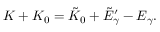Convert formula to latex. <formula><loc_0><loc_0><loc_500><loc_500>K + K _ { 0 } = \tilde { K } _ { 0 } + \tilde { E } _ { \gamma } ^ { \prime } - E _ { \gamma } .</formula> 